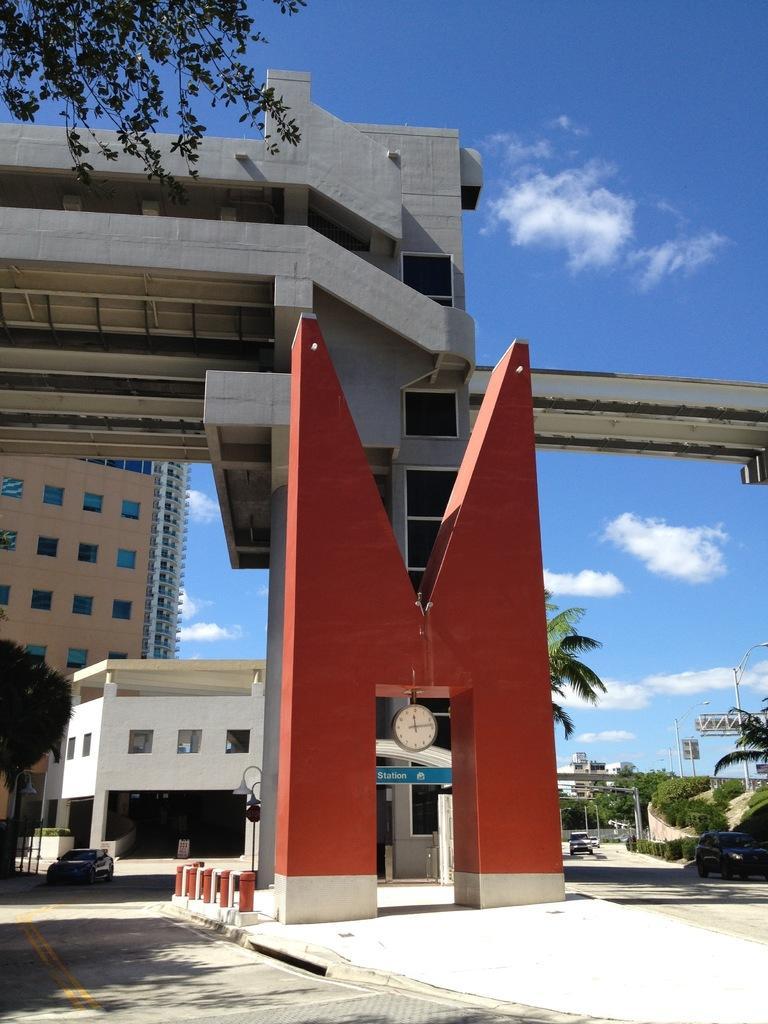Describe this image in one or two sentences. In this image I can see buildings, fence, trees, poles, windows and the sky. This image is taken may be during a day. 